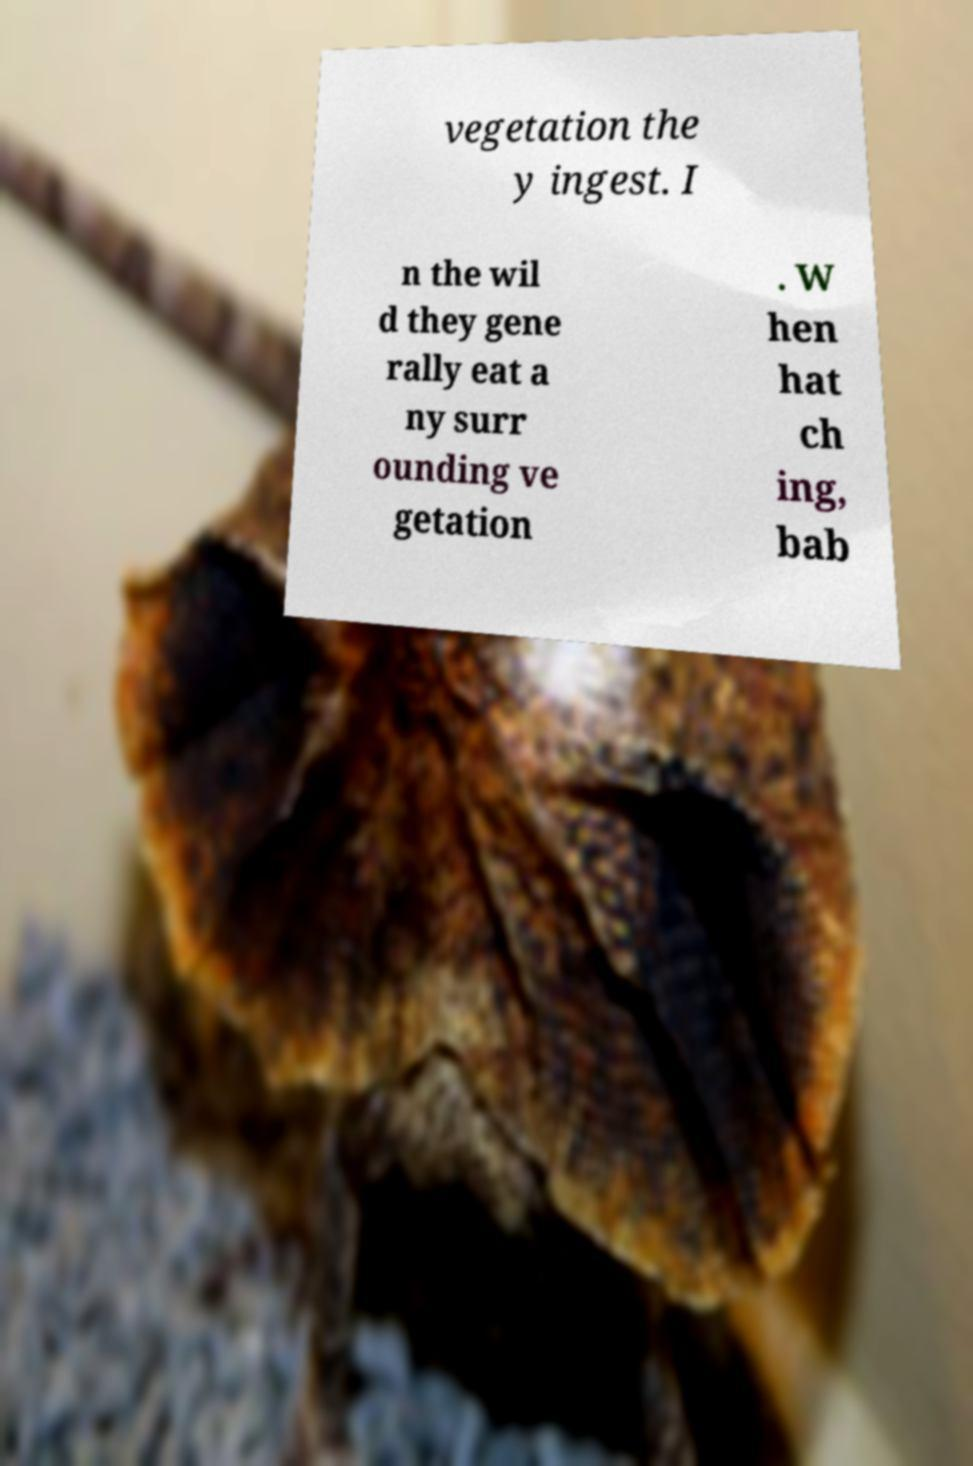Could you assist in decoding the text presented in this image and type it out clearly? vegetation the y ingest. I n the wil d they gene rally eat a ny surr ounding ve getation . W hen hat ch ing, bab 